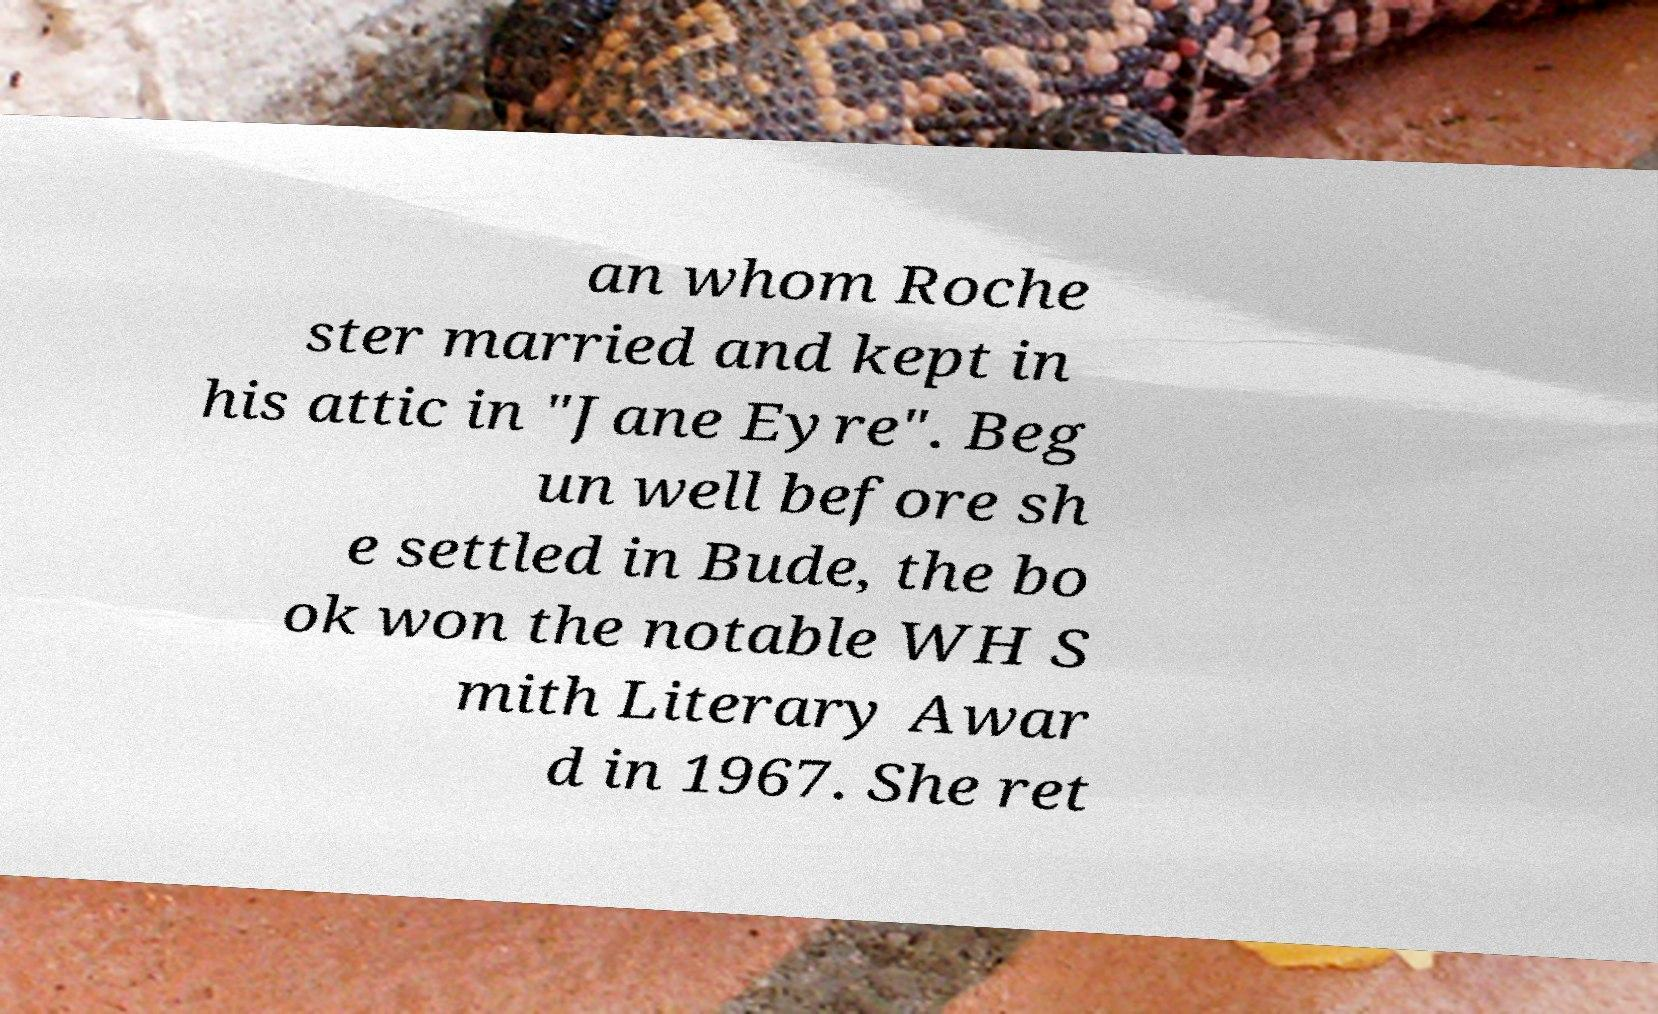What messages or text are displayed in this image? I need them in a readable, typed format. an whom Roche ster married and kept in his attic in "Jane Eyre". Beg un well before sh e settled in Bude, the bo ok won the notable WH S mith Literary Awar d in 1967. She ret 